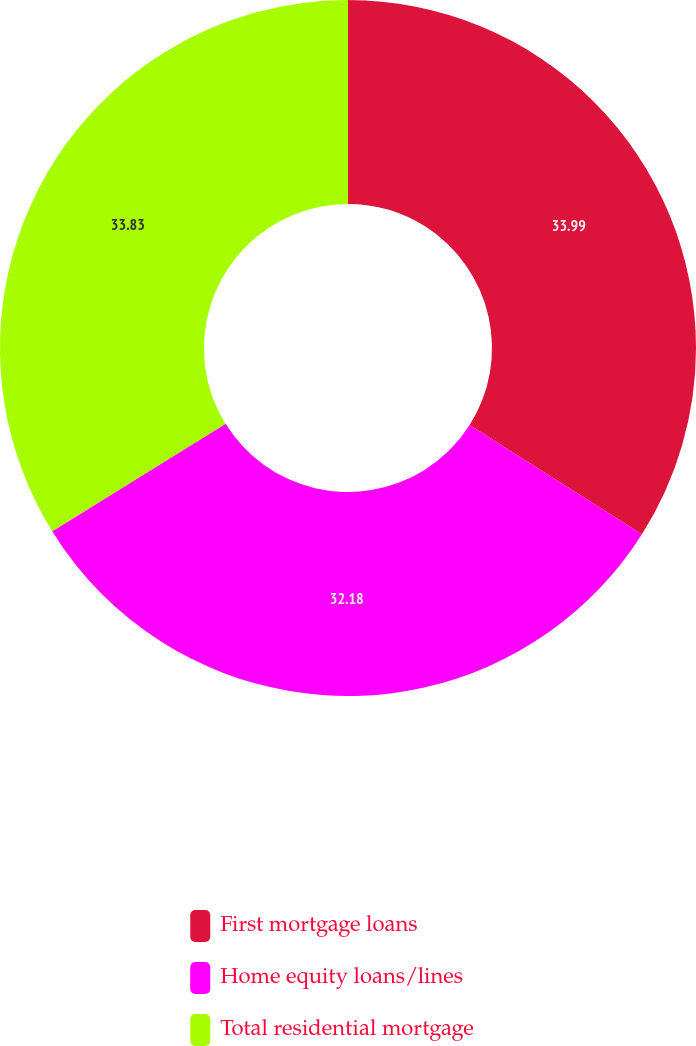Convert chart. <chart><loc_0><loc_0><loc_500><loc_500><pie_chart><fcel>First mortgage loans<fcel>Home equity loans/lines<fcel>Total residential mortgage<nl><fcel>33.99%<fcel>32.18%<fcel>33.83%<nl></chart> 